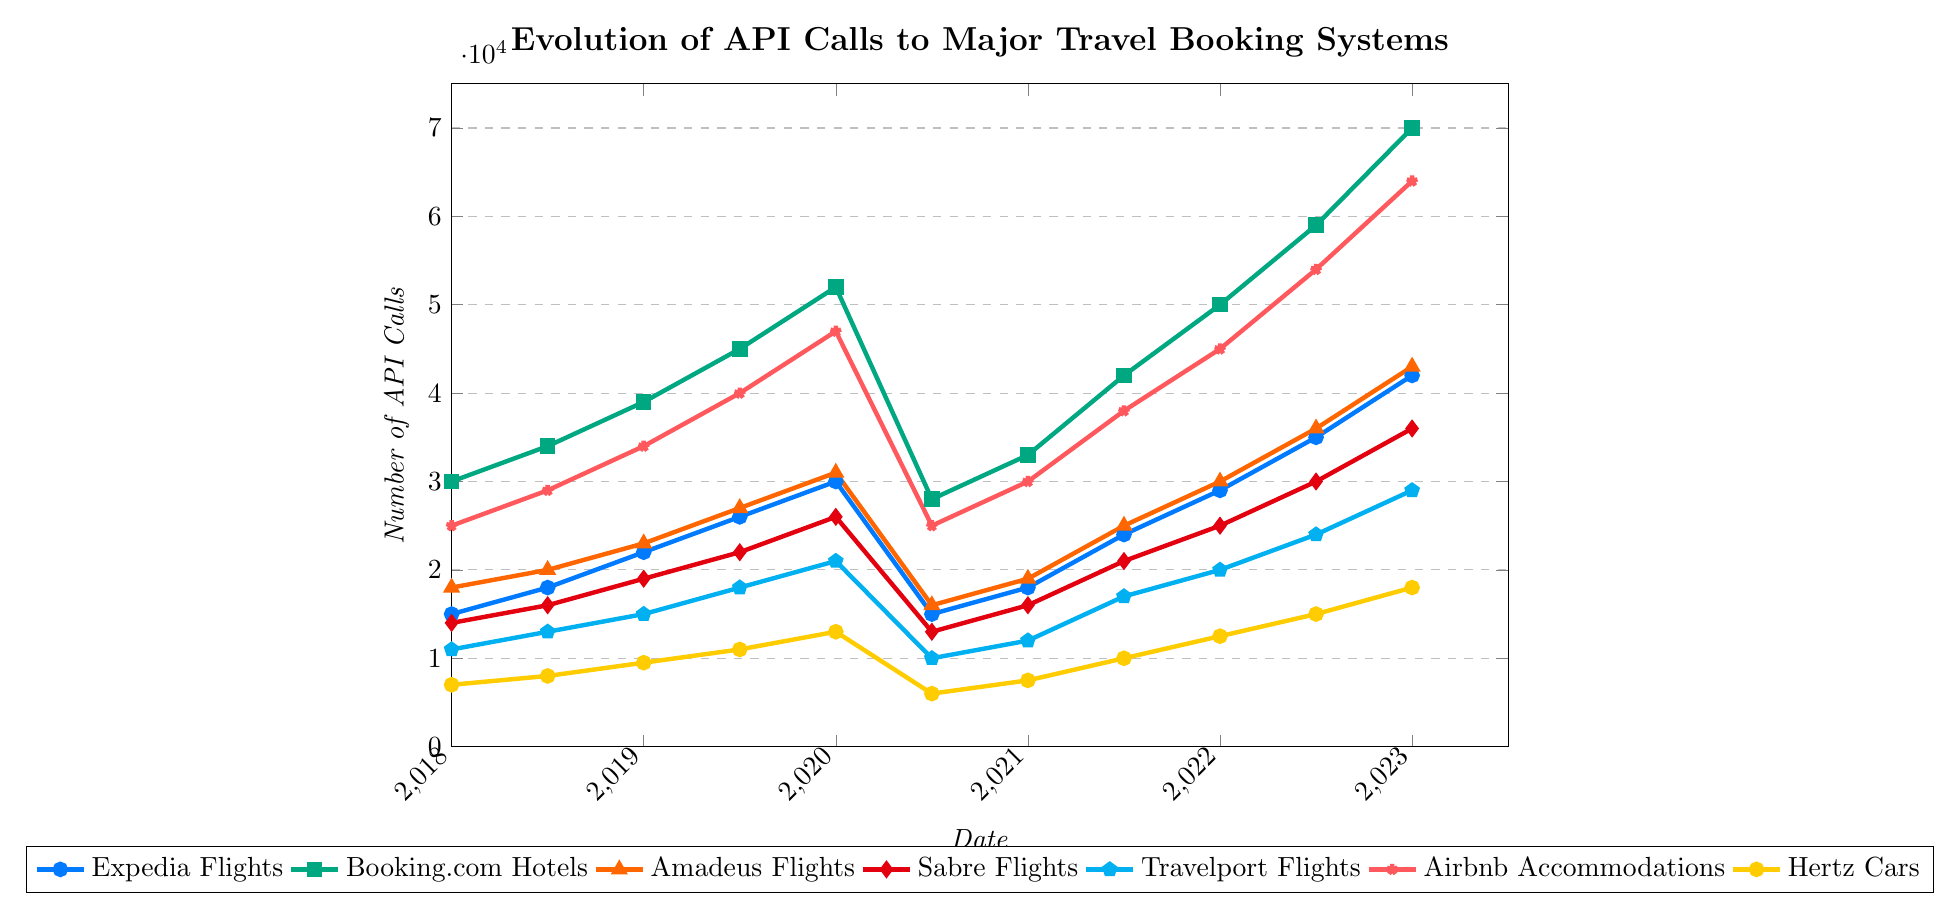Which service shows the highest number of API calls in January 2023? Look at the markers representing different services in January 2023 and find the one corresponding to the highest value. The Booking.com Hotels line reaches 70,000 API calls.
Answer: Booking.com Hotels What is the overall trend for Expedia Flights from 2018 to 2023? Trace the line for Expedia Flights from 2018 to 2023. It generally increases from 15,000 to 42,000 except for a significant dip in mid-2020.
Answer: Increasing How did the number of Airbnb Accommodations API calls change between January 2020 and July 2020? Identify the values in January and July 2020 for Airbnb Accommodations. The markers show a drop from 47,000 to 25,000 API calls.
Answer: Decreased Compare the number of API calls for Hertz Cars and Expedia Hotels in mid-2019. Which is higher, and by how much? Look at the mid-2019 values for Hertz Cars (11,000) and Expedia Hotels (33,000). The difference is 33,000 - 11,000.
Answer: Expedia Hotels by 22,000 What is the sum of API calls for Amadeus Flights and Sabre Flights in January 2021? Add the January 2021 API calls for Amadeus Flights (19,000) and Sabre Flights (16,000).
Answer: 35,000 In which year does Booking.com Hotels experience the most significant growth, and how much does it grow? Compare yearly increases in API calls for Booking.com Hotels. The most significant growth is between 2022 and 2023, from 59,000 to 70,000, a growth of 11,000.
Answer: 2022-2023, 11,000 How do the values of Expedia Flights in January 2023 compare with Airbnb Accommodations in mid-2022? Compare the January 2023 value for Expedia Flights (42,000) with the mid-2022 value for Airbnb Accommodations (54,000).
Answer: Lower What was the difference in API calls between Travelport Flights and Hertz Cars in July 2020? Subtract Hertz Cars (6,000) from Travelport Flights (10,000) in July 2020.
Answer: 4,000 Calculate the average number of API calls for Expedia Hotels in the years 2018, 2019, and 2020. Sum the values for Expedia Hotels in 2018 (22,000), 2019 (29,000), and 2020 (38,000), then divide by 3.
Answer: 29,667 